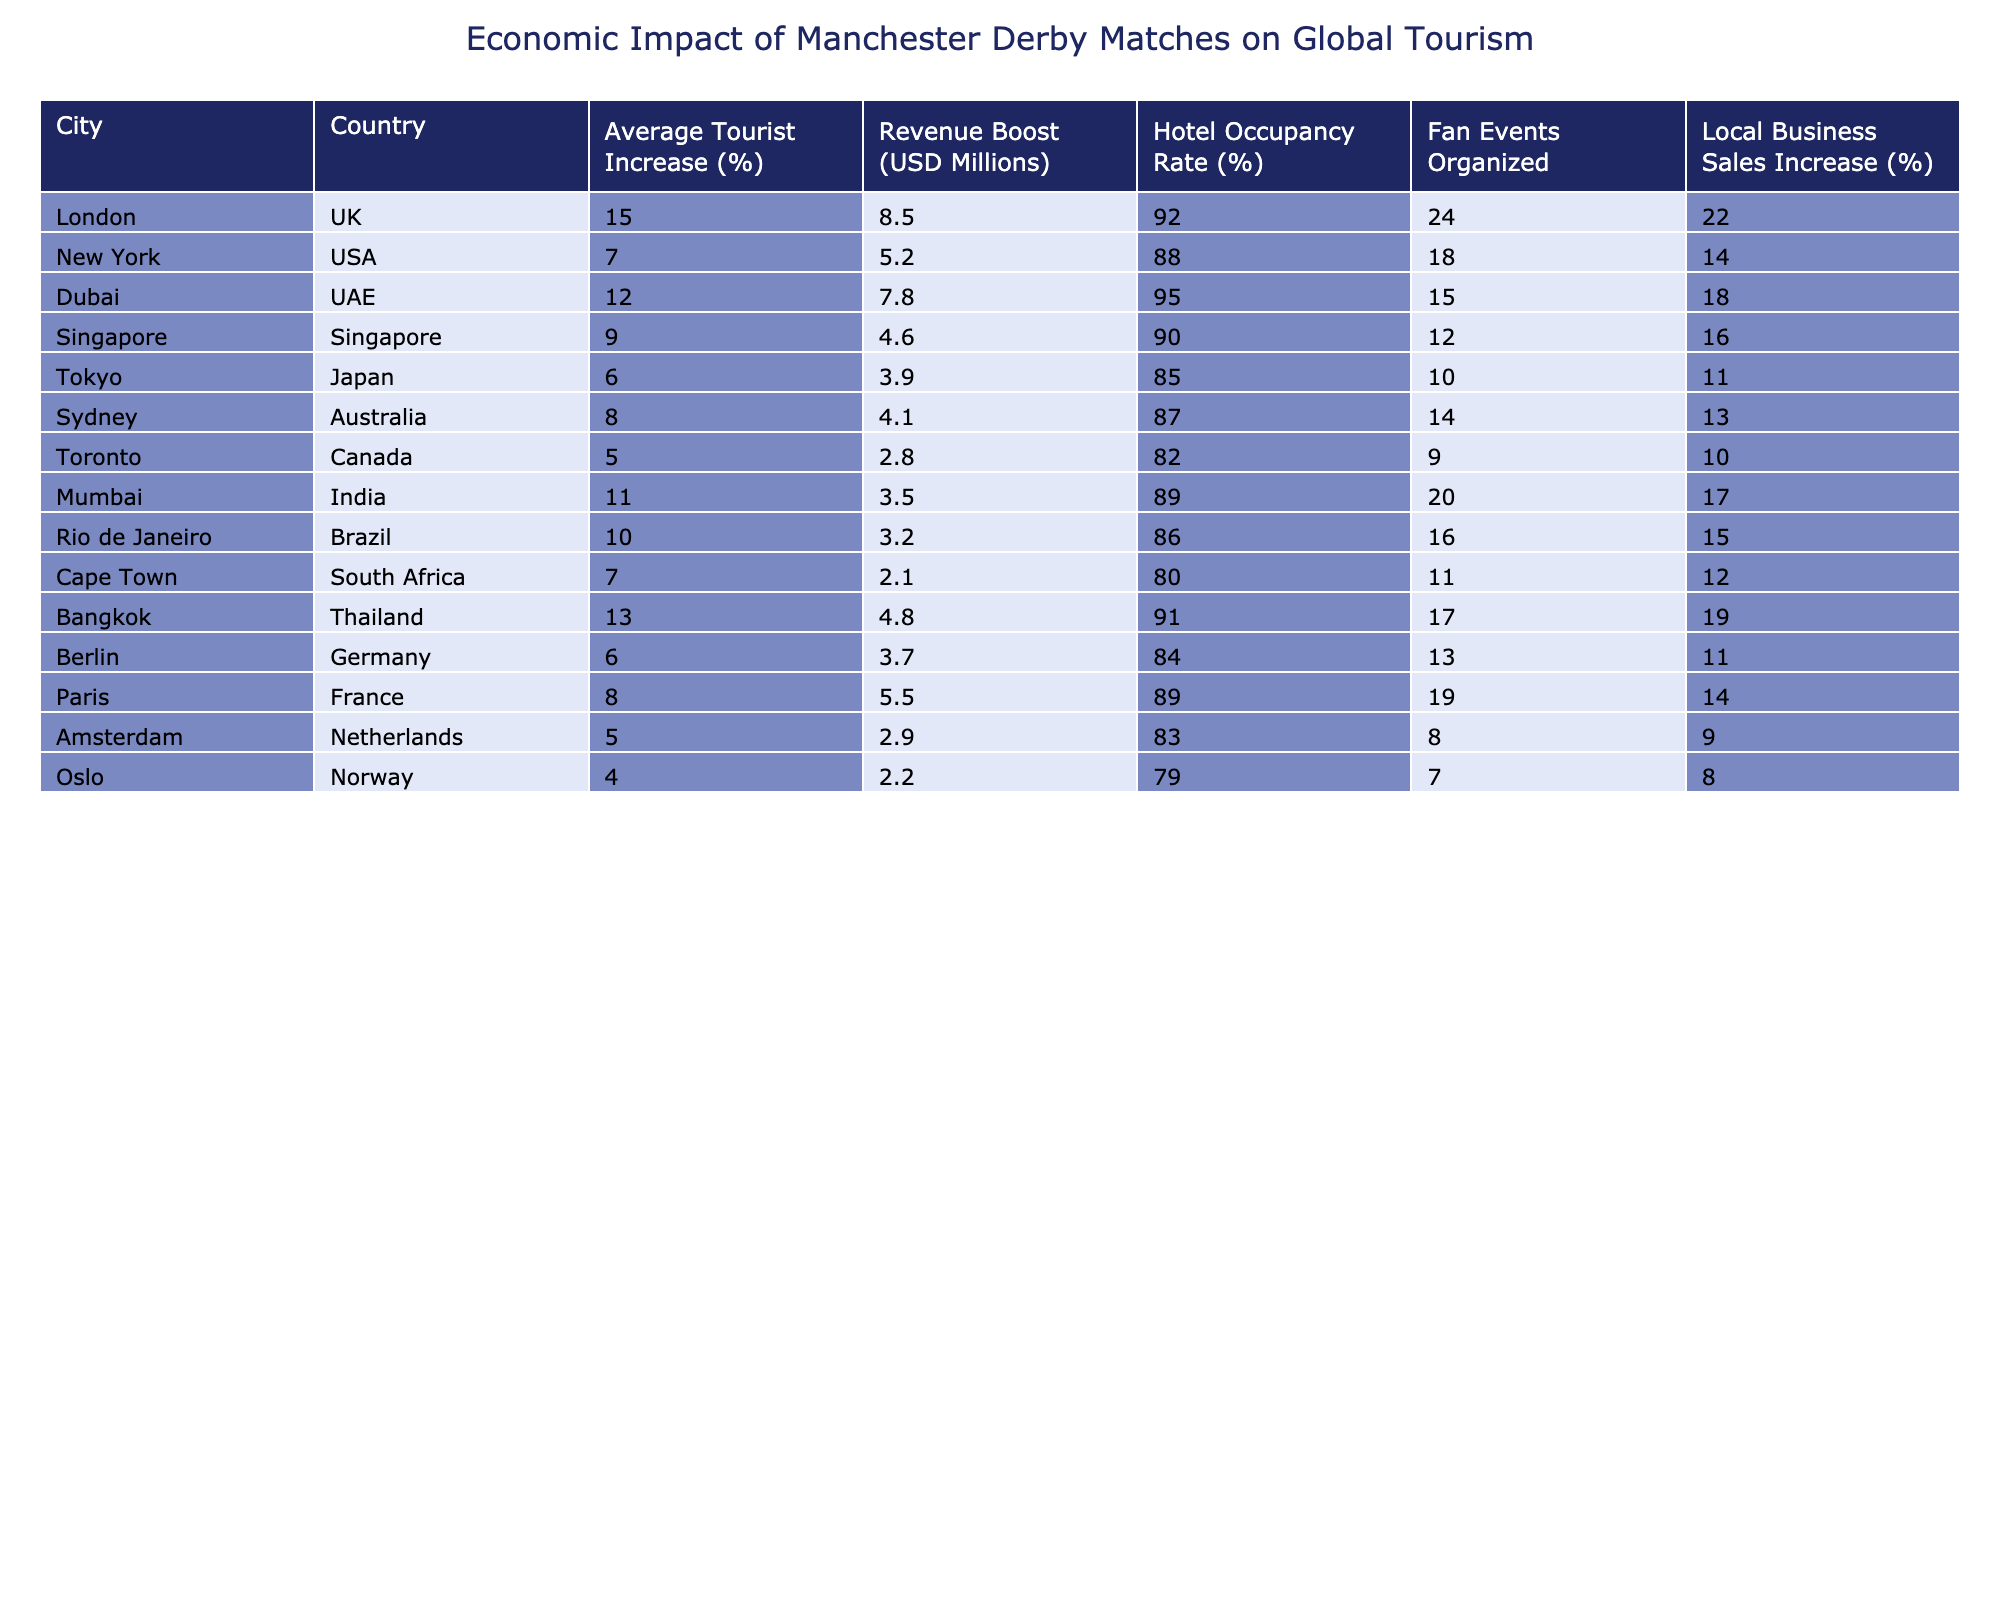What city has the highest average tourist increase percentage? By examining the table, we find that Bangkok has the highest average tourist increase percentage at 13%.
Answer: Bangkok What is the revenue boost attributed to the Manchester derby match in New York? According to the table, New York has a revenue boost of 5.2 million USD from the Manchester derby match.
Answer: 5.2 million USD Which city has the lowest hotel occupancy rate among those listed? Upon reviewing the table, Oslo has the lowest hotel occupancy rate at 79%.
Answer: Oslo How many fan events were organized in Cape Town? The table indicates that 11 fan events were organized in Cape Town during the derby matches.
Answer: 11 What is the average revenue boost for the cities listed in the table? To find the average, sum all the revenue boosts (8.5 + 5.2 + 7.8 + 4.6 + 3.9 + 4.1 + 2.8 + 3.5 + 3.2 + 2.1 + 4.8 + 3.7 + 5.5 + 2.9 + 2.2 = 56.1), then divide by the number of cities (15) to get approximately 3.74 million USD.
Answer: 3.74 million USD Is the local business sales increase in Toronto higher than that in Sydney? The table shows local business sales increase in Toronto is 10%, while in Sydney it is 13%, therefore, it is false that Toronto's increase is higher.
Answer: No Which two cities have the same percentage increase in local business sales? By comparing local business sales increases, we see that the percentages for Mumbai (17%) and Bangkok (19%) are the highest while Berlin (11%) and Tokyo (11%) match each other.
Answer: Berlin and Tokyo What is the combined tourist increase percentage for London and Dubai? By adding their percentages together (15% + 12%), the combined percentage is 27%.
Answer: 27% In which city is the hotel occupancy rate above 90%? The cities with hotel occupancy rates above 90% are London (92%), Dubai (95%), and Bangkok (91%).
Answer: London, Dubai, Bangkok Which city has the highest local business sales increase, and what is that percentage? Upon reviewing the table, we see that Bangkok has the highest local business sales increase at 19%.
Answer: Bangkok, 19% Which country has the highest revenue boost from the Manchester derby matches? The table shows that London in the UK has the highest revenue boost of 8.5 million USD from the matches.
Answer: UK, 8.5 million USD 